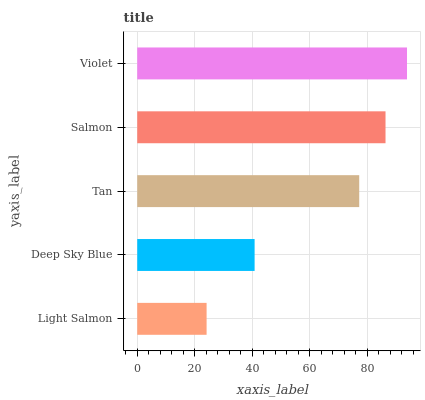Is Light Salmon the minimum?
Answer yes or no. Yes. Is Violet the maximum?
Answer yes or no. Yes. Is Deep Sky Blue the minimum?
Answer yes or no. No. Is Deep Sky Blue the maximum?
Answer yes or no. No. Is Deep Sky Blue greater than Light Salmon?
Answer yes or no. Yes. Is Light Salmon less than Deep Sky Blue?
Answer yes or no. Yes. Is Light Salmon greater than Deep Sky Blue?
Answer yes or no. No. Is Deep Sky Blue less than Light Salmon?
Answer yes or no. No. Is Tan the high median?
Answer yes or no. Yes. Is Tan the low median?
Answer yes or no. Yes. Is Violet the high median?
Answer yes or no. No. Is Salmon the low median?
Answer yes or no. No. 